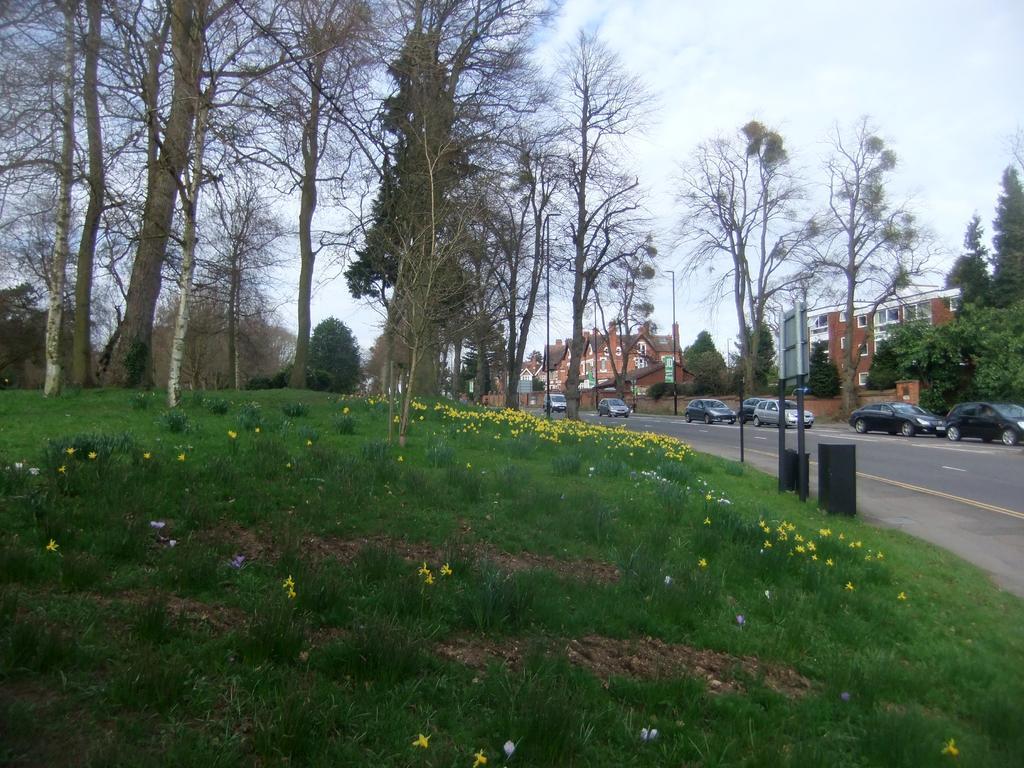Describe this image in one or two sentences. In this picture we can see the trees, buildings, windows, poles, lights, board, vehicles. In the background of the image we can see the grass, flowers and the road. At the top of the image we can see the clouds in the sky. 